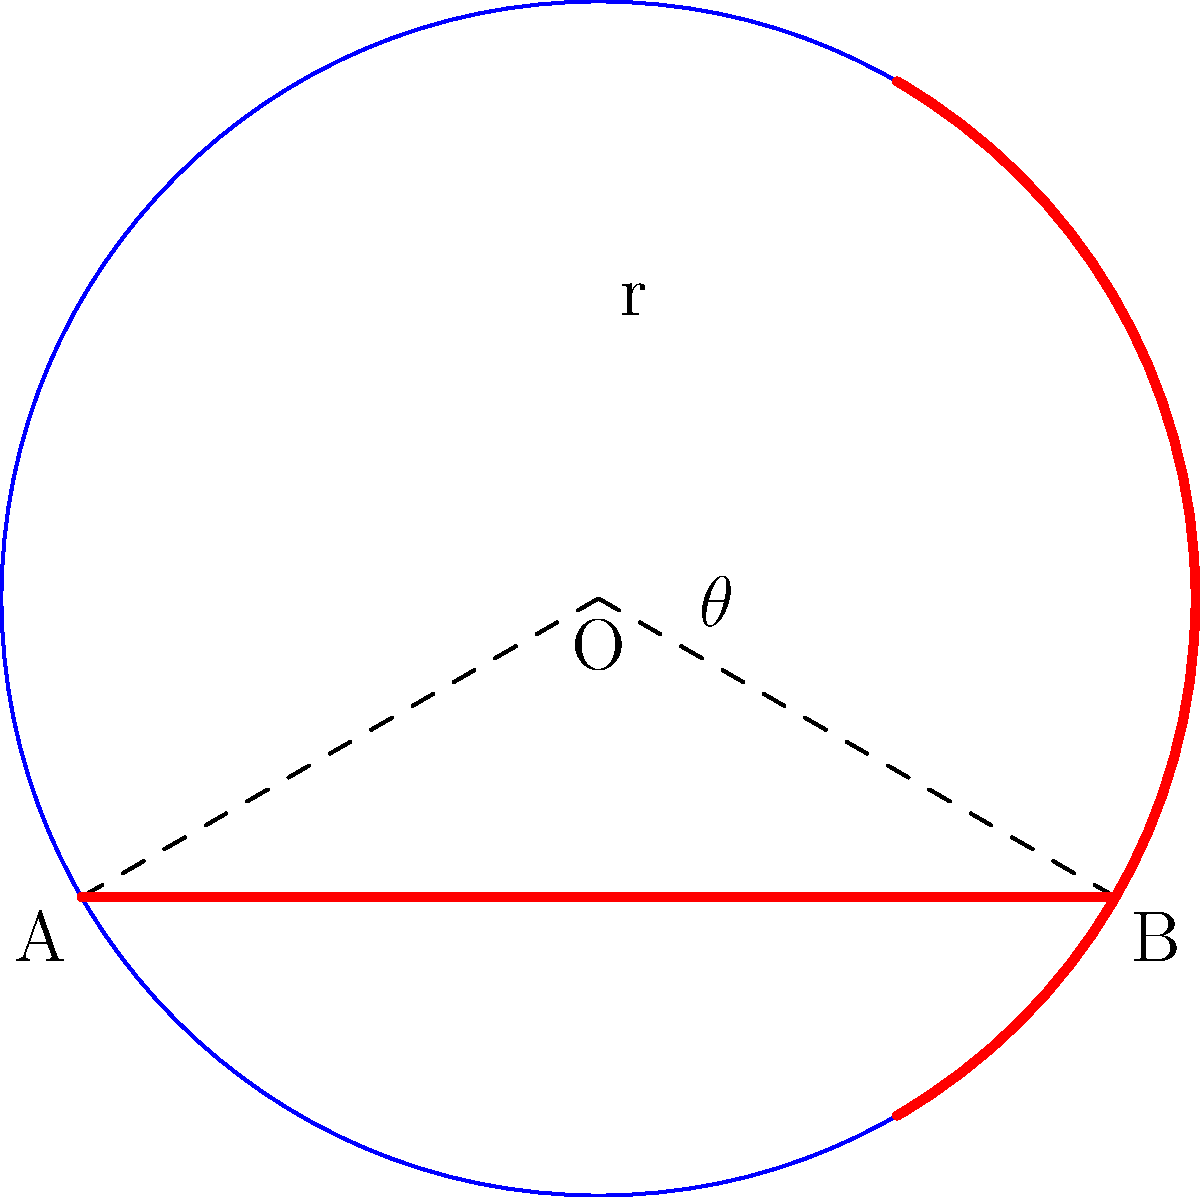Back in your playing days, the three-point line was introduced, changing the game significantly. In a regulation basketball court, the three-point line forms an arc with a radius of 23.75 feet from the center of the basket. If the central angle of this arc is 140°, what is the area of the court section bounded by the three-point line and the baseline (represented by the red section in the diagram)? Round your answer to the nearest square foot. Let's approach this step-by-step:

1) First, we need to recall the formula for the area of a sector:
   Area of sector = $\frac{\theta}{360°} \cdot \pi r^2$, where $\theta$ is in degrees and $r$ is the radius.

2) We're given:
   - Radius (r) = 23.75 feet
   - Central angle ($\theta$) = 140°

3) Let's plug these into our formula:
   Area of sector = $\frac{140°}{360°} \cdot \pi \cdot (23.75\text{ ft})^2$

4) Simplify:
   Area of sector = $\frac{7}{18} \cdot \pi \cdot 564.0625\text{ sq ft}$
                  ≈ 686.27 sq ft

5) However, this is not our final answer. We need to subtract the area of the triangle formed by the two radii and the baseline.

6) To find the area of this triangle, we can use the formula:
   Area of triangle = $\frac{1}{2} \cdot base \cdot height$

7) The base is the chord length, which we can find using:
   chord length = $2r \sin(\frac{\theta}{2})$
                = $2 \cdot 23.75 \cdot \sin(70°)$
                ≈ 44.62 ft

8) The height of the triangle is:
   $h = r \cos(\frac{\theta}{2}) = 23.75 \cdot \cos(70°) \approx 8.13$ ft

9) So the area of the triangle is:
   $\frac{1}{2} \cdot 44.62 \cdot 8.13 \approx 181.28$ sq ft

10) The final area is the difference:
    686.27 - 181.28 ≈ 504.99 sq ft

11) Rounding to the nearest square foot:
    505 sq ft
Answer: 505 sq ft 